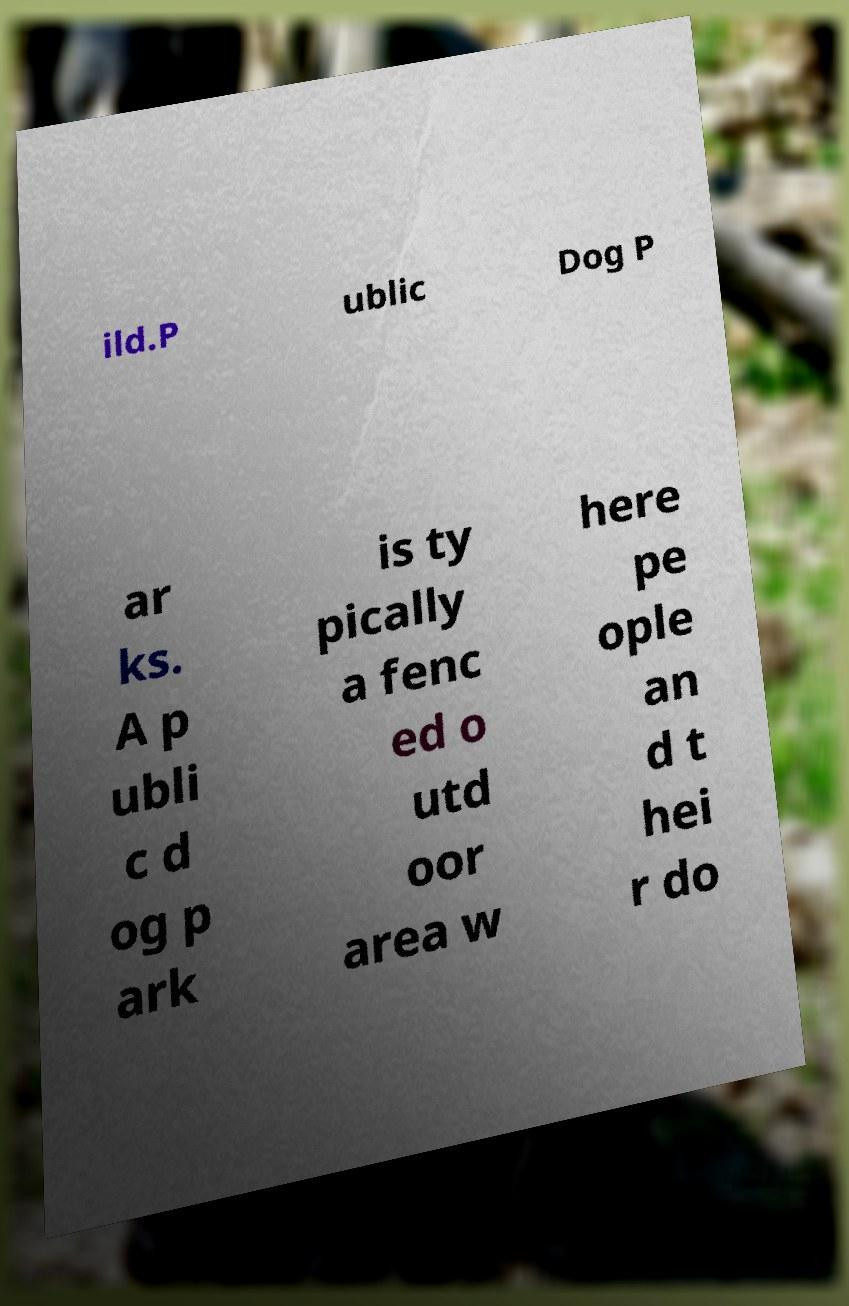Please read and relay the text visible in this image. What does it say? ild.P ublic Dog P ar ks. A p ubli c d og p ark is ty pically a fenc ed o utd oor area w here pe ople an d t hei r do 